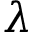Convert formula to latex. <formula><loc_0><loc_0><loc_500><loc_500>\lambda</formula> 